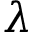Convert formula to latex. <formula><loc_0><loc_0><loc_500><loc_500>\lambda</formula> 